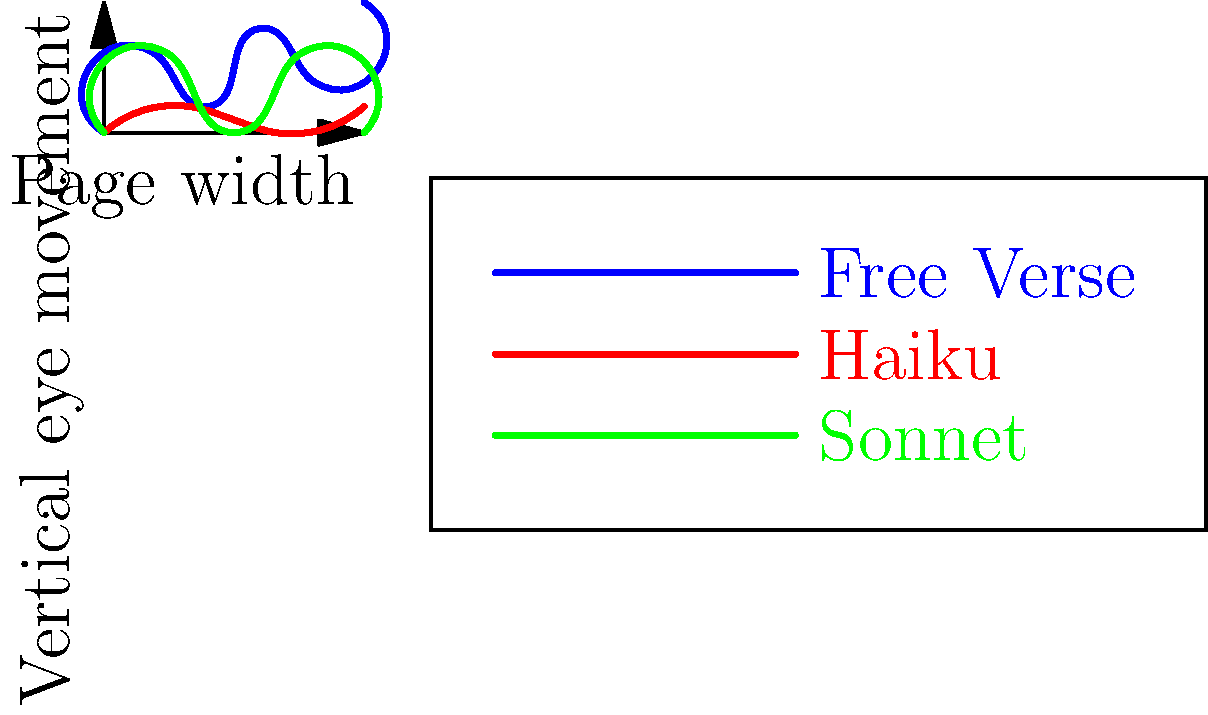Analyzing the eye movement patterns depicted in the graph, which poetic form exhibits the most varied vertical eye movements, potentially influencing the reader's perception of rhythm and structure? To determine which poetic form exhibits the most varied vertical eye movements, we need to examine the patterns for each form:

1. Free Verse (blue line):
   - Shows irregular ups and downs
   - Covers a wide range of vertical positions
   - No consistent pattern

2. Haiku (red line):
   - Shows a relatively flat pattern
   - Small vertical movements
   - Consistent across the page width

3. Sonnet (green line):
   - Shows a regular up-and-down pattern
   - Moderate vertical range
   - Repeating structure across the page width

Comparing these patterns:
- Free Verse has the most irregular and varied vertical movements
- Haiku has the least vertical variation
- Sonnet shows regular variation but less extreme than Free Verse

The Free Verse pattern indicates that readers' eyes move more unpredictably and cover a wider vertical range when reading this form. This suggests that Free Verse poetry may have a more diverse arrangement of words and lines on the page, leading to more varied eye movements.

This varied eye movement pattern in Free Verse could influence the reader's perception of rhythm and structure by:
1. Creating a sense of unpredictability
2. Encouraging the reader to pause and consider each line individually
3. Potentially emphasizing certain words or phrases through their placement

Therefore, the poetic form exhibiting the most varied vertical eye movements is Free Verse.
Answer: Free Verse 